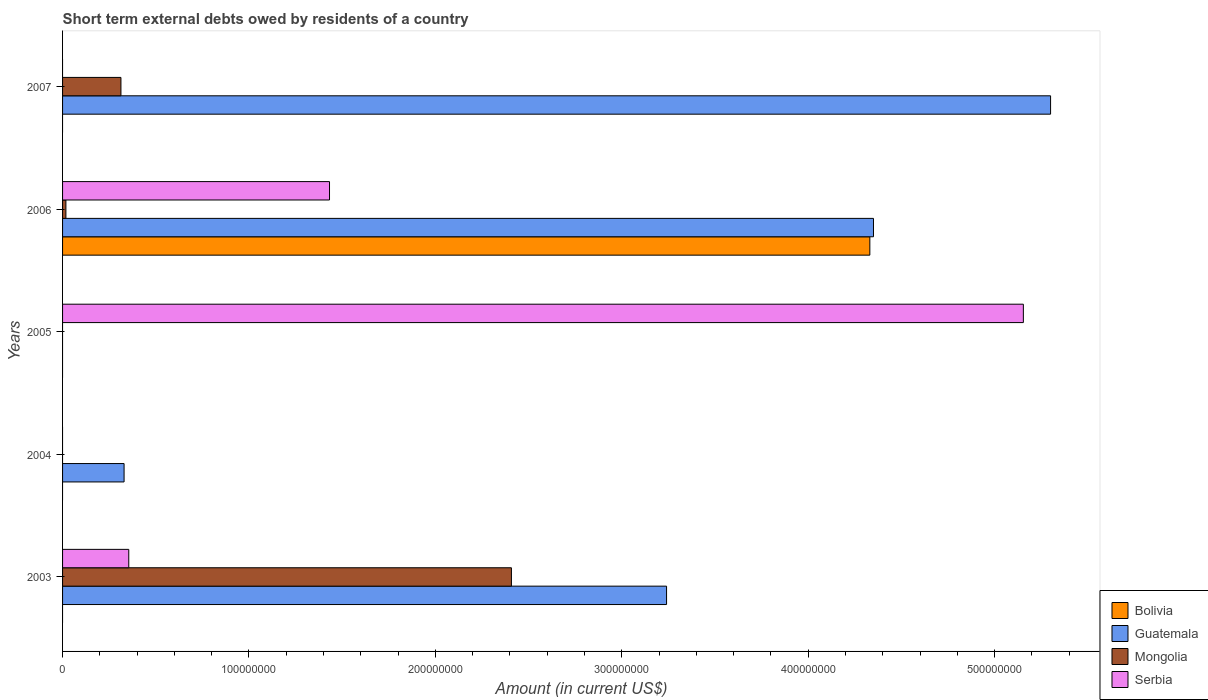How many different coloured bars are there?
Your answer should be compact. 4. Are the number of bars on each tick of the Y-axis equal?
Provide a short and direct response. No. How many bars are there on the 5th tick from the bottom?
Provide a succinct answer. 2. What is the amount of short-term external debts owed by residents in Guatemala in 2004?
Keep it short and to the point. 3.30e+07. Across all years, what is the maximum amount of short-term external debts owed by residents in Guatemala?
Ensure brevity in your answer.  5.30e+08. What is the total amount of short-term external debts owed by residents in Bolivia in the graph?
Give a very brief answer. 4.33e+08. What is the difference between the amount of short-term external debts owed by residents in Guatemala in 2004 and that in 2007?
Your answer should be compact. -4.97e+08. What is the difference between the amount of short-term external debts owed by residents in Serbia in 2005 and the amount of short-term external debts owed by residents in Bolivia in 2003?
Your answer should be compact. 5.15e+08. What is the average amount of short-term external debts owed by residents in Guatemala per year?
Keep it short and to the point. 2.64e+08. In the year 2006, what is the difference between the amount of short-term external debts owed by residents in Bolivia and amount of short-term external debts owed by residents in Mongolia?
Your answer should be compact. 4.31e+08. What is the ratio of the amount of short-term external debts owed by residents in Mongolia in 2003 to that in 2007?
Your answer should be compact. 7.69. Is the amount of short-term external debts owed by residents in Mongolia in 2003 less than that in 2007?
Your response must be concise. No. What is the difference between the highest and the second highest amount of short-term external debts owed by residents in Serbia?
Your response must be concise. 3.72e+08. What is the difference between the highest and the lowest amount of short-term external debts owed by residents in Guatemala?
Your answer should be very brief. 5.30e+08. Is the sum of the amount of short-term external debts owed by residents in Mongolia in 2003 and 2006 greater than the maximum amount of short-term external debts owed by residents in Bolivia across all years?
Offer a terse response. No. Is it the case that in every year, the sum of the amount of short-term external debts owed by residents in Guatemala and amount of short-term external debts owed by residents in Bolivia is greater than the sum of amount of short-term external debts owed by residents in Serbia and amount of short-term external debts owed by residents in Mongolia?
Ensure brevity in your answer.  No. Is it the case that in every year, the sum of the amount of short-term external debts owed by residents in Serbia and amount of short-term external debts owed by residents in Guatemala is greater than the amount of short-term external debts owed by residents in Mongolia?
Give a very brief answer. Yes. How many bars are there?
Your answer should be compact. 11. What is the difference between two consecutive major ticks on the X-axis?
Your response must be concise. 1.00e+08. Does the graph contain grids?
Give a very brief answer. No. Where does the legend appear in the graph?
Make the answer very short. Bottom right. How many legend labels are there?
Your answer should be very brief. 4. How are the legend labels stacked?
Ensure brevity in your answer.  Vertical. What is the title of the graph?
Give a very brief answer. Short term external debts owed by residents of a country. Does "Aruba" appear as one of the legend labels in the graph?
Your answer should be compact. No. What is the label or title of the Y-axis?
Your answer should be compact. Years. What is the Amount (in current US$) in Guatemala in 2003?
Offer a very short reply. 3.24e+08. What is the Amount (in current US$) of Mongolia in 2003?
Give a very brief answer. 2.41e+08. What is the Amount (in current US$) in Serbia in 2003?
Ensure brevity in your answer.  3.55e+07. What is the Amount (in current US$) of Guatemala in 2004?
Keep it short and to the point. 3.30e+07. What is the Amount (in current US$) of Serbia in 2004?
Offer a terse response. 0. What is the Amount (in current US$) of Mongolia in 2005?
Your response must be concise. 0. What is the Amount (in current US$) in Serbia in 2005?
Make the answer very short. 5.15e+08. What is the Amount (in current US$) of Bolivia in 2006?
Keep it short and to the point. 4.33e+08. What is the Amount (in current US$) in Guatemala in 2006?
Your response must be concise. 4.35e+08. What is the Amount (in current US$) of Mongolia in 2006?
Your answer should be compact. 1.79e+06. What is the Amount (in current US$) in Serbia in 2006?
Give a very brief answer. 1.43e+08. What is the Amount (in current US$) in Guatemala in 2007?
Ensure brevity in your answer.  5.30e+08. What is the Amount (in current US$) in Mongolia in 2007?
Provide a short and direct response. 3.13e+07. What is the Amount (in current US$) in Serbia in 2007?
Make the answer very short. 0. Across all years, what is the maximum Amount (in current US$) of Bolivia?
Offer a terse response. 4.33e+08. Across all years, what is the maximum Amount (in current US$) in Guatemala?
Your response must be concise. 5.30e+08. Across all years, what is the maximum Amount (in current US$) in Mongolia?
Keep it short and to the point. 2.41e+08. Across all years, what is the maximum Amount (in current US$) of Serbia?
Provide a succinct answer. 5.15e+08. Across all years, what is the minimum Amount (in current US$) of Bolivia?
Provide a succinct answer. 0. Across all years, what is the minimum Amount (in current US$) in Guatemala?
Give a very brief answer. 0. What is the total Amount (in current US$) of Bolivia in the graph?
Make the answer very short. 4.33e+08. What is the total Amount (in current US$) in Guatemala in the graph?
Your answer should be compact. 1.32e+09. What is the total Amount (in current US$) in Mongolia in the graph?
Ensure brevity in your answer.  2.74e+08. What is the total Amount (in current US$) of Serbia in the graph?
Make the answer very short. 6.94e+08. What is the difference between the Amount (in current US$) in Guatemala in 2003 and that in 2004?
Your answer should be compact. 2.91e+08. What is the difference between the Amount (in current US$) of Serbia in 2003 and that in 2005?
Your response must be concise. -4.80e+08. What is the difference between the Amount (in current US$) in Guatemala in 2003 and that in 2006?
Your answer should be very brief. -1.11e+08. What is the difference between the Amount (in current US$) of Mongolia in 2003 and that in 2006?
Offer a very short reply. 2.39e+08. What is the difference between the Amount (in current US$) in Serbia in 2003 and that in 2006?
Make the answer very short. -1.08e+08. What is the difference between the Amount (in current US$) in Guatemala in 2003 and that in 2007?
Give a very brief answer. -2.06e+08. What is the difference between the Amount (in current US$) of Mongolia in 2003 and that in 2007?
Your answer should be very brief. 2.09e+08. What is the difference between the Amount (in current US$) of Guatemala in 2004 and that in 2006?
Keep it short and to the point. -4.02e+08. What is the difference between the Amount (in current US$) in Guatemala in 2004 and that in 2007?
Keep it short and to the point. -4.97e+08. What is the difference between the Amount (in current US$) in Serbia in 2005 and that in 2006?
Your answer should be compact. 3.72e+08. What is the difference between the Amount (in current US$) of Guatemala in 2006 and that in 2007?
Ensure brevity in your answer.  -9.50e+07. What is the difference between the Amount (in current US$) in Mongolia in 2006 and that in 2007?
Your answer should be very brief. -2.95e+07. What is the difference between the Amount (in current US$) of Guatemala in 2003 and the Amount (in current US$) of Serbia in 2005?
Make the answer very short. -1.91e+08. What is the difference between the Amount (in current US$) of Mongolia in 2003 and the Amount (in current US$) of Serbia in 2005?
Ensure brevity in your answer.  -2.75e+08. What is the difference between the Amount (in current US$) in Guatemala in 2003 and the Amount (in current US$) in Mongolia in 2006?
Your response must be concise. 3.22e+08. What is the difference between the Amount (in current US$) in Guatemala in 2003 and the Amount (in current US$) in Serbia in 2006?
Your answer should be compact. 1.81e+08. What is the difference between the Amount (in current US$) in Mongolia in 2003 and the Amount (in current US$) in Serbia in 2006?
Ensure brevity in your answer.  9.76e+07. What is the difference between the Amount (in current US$) of Guatemala in 2003 and the Amount (in current US$) of Mongolia in 2007?
Keep it short and to the point. 2.93e+08. What is the difference between the Amount (in current US$) in Guatemala in 2004 and the Amount (in current US$) in Serbia in 2005?
Your answer should be very brief. -4.82e+08. What is the difference between the Amount (in current US$) of Guatemala in 2004 and the Amount (in current US$) of Mongolia in 2006?
Keep it short and to the point. 3.12e+07. What is the difference between the Amount (in current US$) in Guatemala in 2004 and the Amount (in current US$) in Serbia in 2006?
Provide a succinct answer. -1.10e+08. What is the difference between the Amount (in current US$) in Guatemala in 2004 and the Amount (in current US$) in Mongolia in 2007?
Your answer should be very brief. 1.69e+06. What is the difference between the Amount (in current US$) of Bolivia in 2006 and the Amount (in current US$) of Guatemala in 2007?
Make the answer very short. -9.70e+07. What is the difference between the Amount (in current US$) in Bolivia in 2006 and the Amount (in current US$) in Mongolia in 2007?
Ensure brevity in your answer.  4.02e+08. What is the difference between the Amount (in current US$) in Guatemala in 2006 and the Amount (in current US$) in Mongolia in 2007?
Ensure brevity in your answer.  4.04e+08. What is the average Amount (in current US$) in Bolivia per year?
Your response must be concise. 8.66e+07. What is the average Amount (in current US$) of Guatemala per year?
Make the answer very short. 2.64e+08. What is the average Amount (in current US$) in Mongolia per year?
Give a very brief answer. 5.48e+07. What is the average Amount (in current US$) in Serbia per year?
Offer a terse response. 1.39e+08. In the year 2003, what is the difference between the Amount (in current US$) in Guatemala and Amount (in current US$) in Mongolia?
Offer a terse response. 8.32e+07. In the year 2003, what is the difference between the Amount (in current US$) of Guatemala and Amount (in current US$) of Serbia?
Offer a very short reply. 2.88e+08. In the year 2003, what is the difference between the Amount (in current US$) in Mongolia and Amount (in current US$) in Serbia?
Your response must be concise. 2.05e+08. In the year 2006, what is the difference between the Amount (in current US$) of Bolivia and Amount (in current US$) of Guatemala?
Give a very brief answer. -1.95e+06. In the year 2006, what is the difference between the Amount (in current US$) of Bolivia and Amount (in current US$) of Mongolia?
Give a very brief answer. 4.31e+08. In the year 2006, what is the difference between the Amount (in current US$) in Bolivia and Amount (in current US$) in Serbia?
Your answer should be very brief. 2.90e+08. In the year 2006, what is the difference between the Amount (in current US$) in Guatemala and Amount (in current US$) in Mongolia?
Ensure brevity in your answer.  4.33e+08. In the year 2006, what is the difference between the Amount (in current US$) in Guatemala and Amount (in current US$) in Serbia?
Ensure brevity in your answer.  2.92e+08. In the year 2006, what is the difference between the Amount (in current US$) in Mongolia and Amount (in current US$) in Serbia?
Provide a short and direct response. -1.41e+08. In the year 2007, what is the difference between the Amount (in current US$) in Guatemala and Amount (in current US$) in Mongolia?
Your answer should be very brief. 4.99e+08. What is the ratio of the Amount (in current US$) in Guatemala in 2003 to that in 2004?
Provide a short and direct response. 9.82. What is the ratio of the Amount (in current US$) of Serbia in 2003 to that in 2005?
Keep it short and to the point. 0.07. What is the ratio of the Amount (in current US$) of Guatemala in 2003 to that in 2006?
Your answer should be very brief. 0.74. What is the ratio of the Amount (in current US$) in Mongolia in 2003 to that in 2006?
Provide a short and direct response. 134.36. What is the ratio of the Amount (in current US$) of Serbia in 2003 to that in 2006?
Your response must be concise. 0.25. What is the ratio of the Amount (in current US$) of Guatemala in 2003 to that in 2007?
Offer a terse response. 0.61. What is the ratio of the Amount (in current US$) of Mongolia in 2003 to that in 2007?
Give a very brief answer. 7.69. What is the ratio of the Amount (in current US$) of Guatemala in 2004 to that in 2006?
Make the answer very short. 0.08. What is the ratio of the Amount (in current US$) in Guatemala in 2004 to that in 2007?
Give a very brief answer. 0.06. What is the ratio of the Amount (in current US$) in Serbia in 2005 to that in 2006?
Ensure brevity in your answer.  3.6. What is the ratio of the Amount (in current US$) of Guatemala in 2006 to that in 2007?
Give a very brief answer. 0.82. What is the ratio of the Amount (in current US$) of Mongolia in 2006 to that in 2007?
Provide a succinct answer. 0.06. What is the difference between the highest and the second highest Amount (in current US$) in Guatemala?
Ensure brevity in your answer.  9.50e+07. What is the difference between the highest and the second highest Amount (in current US$) in Mongolia?
Provide a short and direct response. 2.09e+08. What is the difference between the highest and the second highest Amount (in current US$) in Serbia?
Your response must be concise. 3.72e+08. What is the difference between the highest and the lowest Amount (in current US$) of Bolivia?
Ensure brevity in your answer.  4.33e+08. What is the difference between the highest and the lowest Amount (in current US$) of Guatemala?
Your answer should be very brief. 5.30e+08. What is the difference between the highest and the lowest Amount (in current US$) of Mongolia?
Offer a terse response. 2.41e+08. What is the difference between the highest and the lowest Amount (in current US$) of Serbia?
Give a very brief answer. 5.15e+08. 